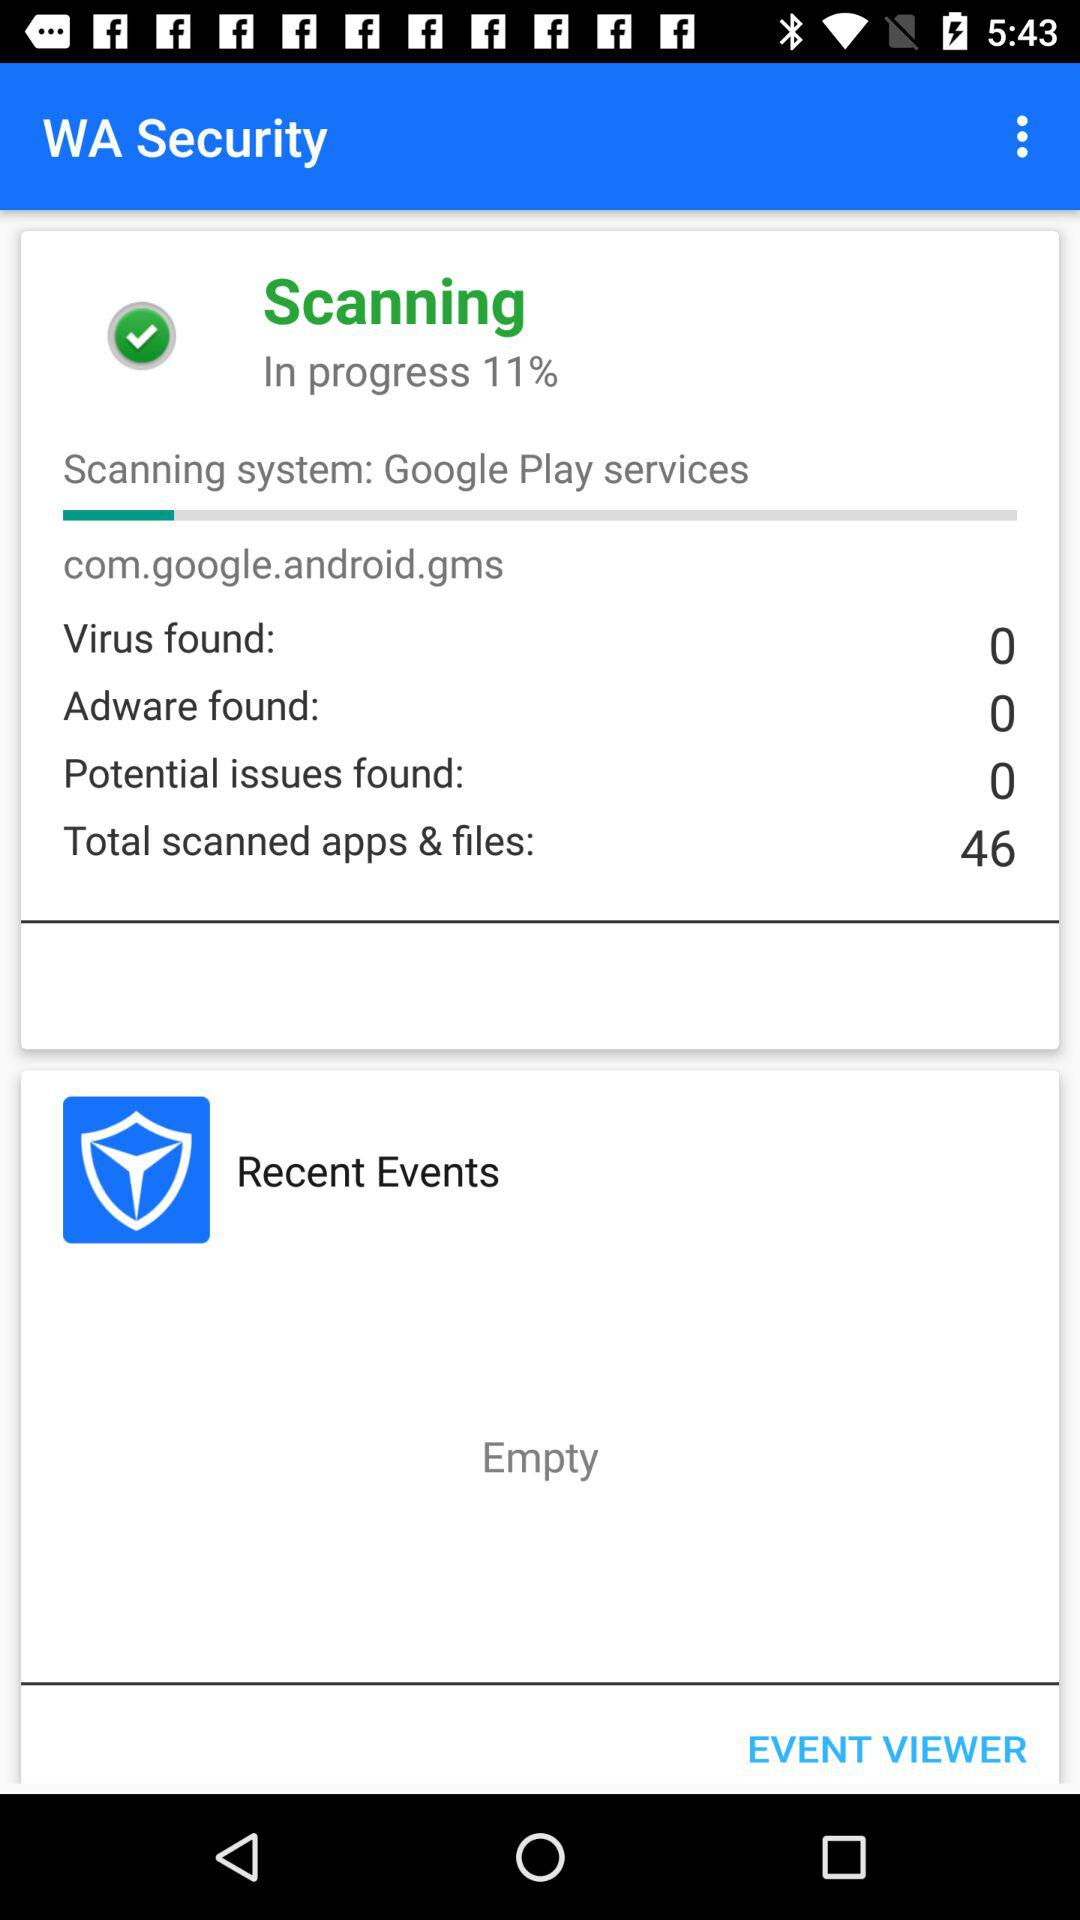What % of scanning has been done? The percentage of scanning that has been done is 11. 